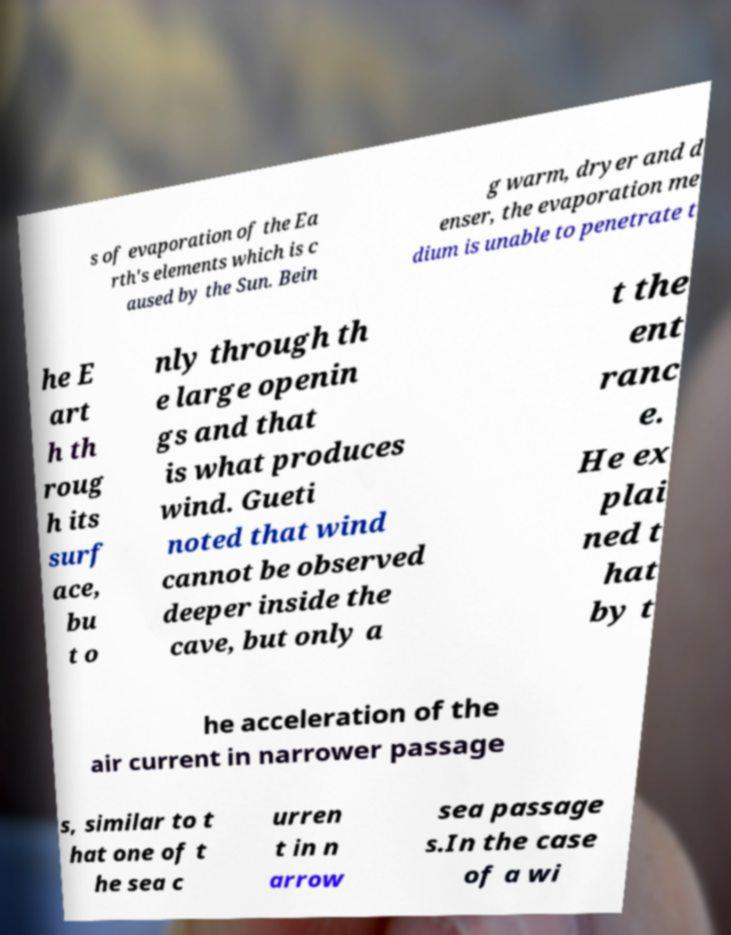Could you assist in decoding the text presented in this image and type it out clearly? s of evaporation of the Ea rth's elements which is c aused by the Sun. Bein g warm, dryer and d enser, the evaporation me dium is unable to penetrate t he E art h th roug h its surf ace, bu t o nly through th e large openin gs and that is what produces wind. Gueti noted that wind cannot be observed deeper inside the cave, but only a t the ent ranc e. He ex plai ned t hat by t he acceleration of the air current in narrower passage s, similar to t hat one of t he sea c urren t in n arrow sea passage s.In the case of a wi 